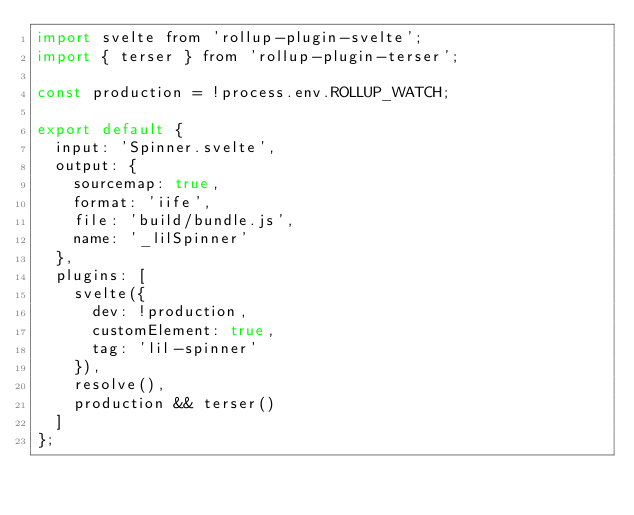Convert code to text. <code><loc_0><loc_0><loc_500><loc_500><_JavaScript_>import svelte from 'rollup-plugin-svelte';
import { terser } from 'rollup-plugin-terser';

const production = !process.env.ROLLUP_WATCH;

export default {
  input: 'Spinner.svelte',
  output: {
    sourcemap: true,
    format: 'iife',
    file: 'build/bundle.js',
    name: '_lilSpinner'
  },
  plugins: [
    svelte({
      dev: !production,
      customElement: true,
      tag: 'lil-spinner'
    }),
    resolve(),
    production && terser()
  ]
};
</code> 